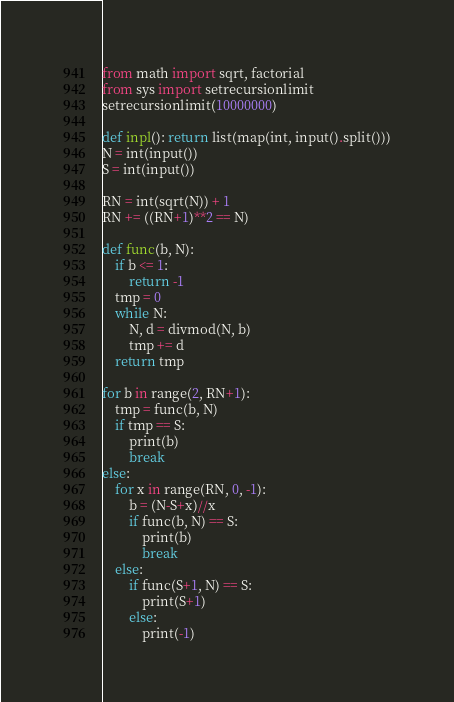<code> <loc_0><loc_0><loc_500><loc_500><_Python_>from math import sqrt, factorial
from sys import setrecursionlimit
setrecursionlimit(10000000)

def inpl(): return list(map(int, input().split()))
N = int(input())
S = int(input())

RN = int(sqrt(N)) + 1
RN += ((RN+1)**2 == N)

def func(b, N):
    if b <= 1:
        return -1
    tmp = 0
    while N:
        N, d = divmod(N, b)
        tmp += d
    return tmp

for b in range(2, RN+1):
    tmp = func(b, N)
    if tmp == S:
        print(b)
        break
else:
    for x in range(RN, 0, -1):
        b = (N-S+x)//x
        if func(b, N) == S:
            print(b)
            break
    else:
        if func(S+1, N) == S:
            print(S+1)
        else:
            print(-1)</code> 